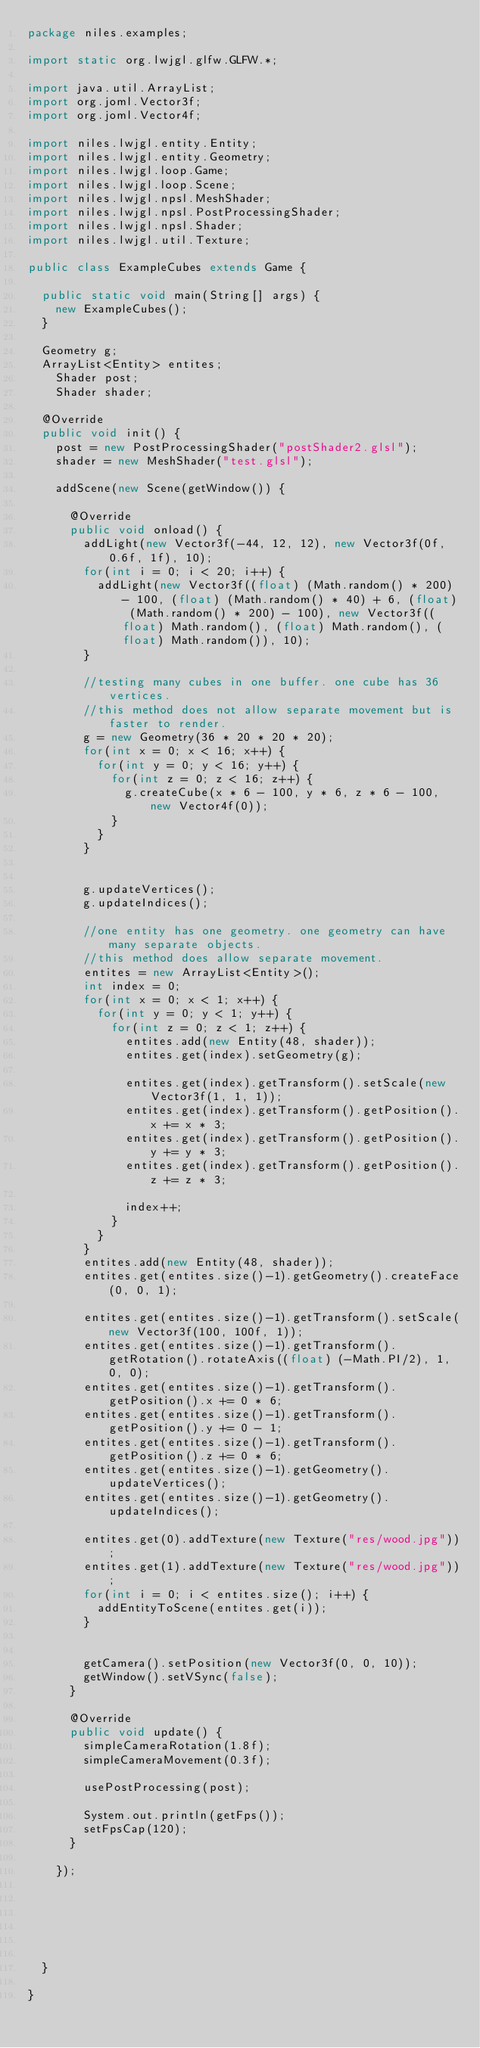<code> <loc_0><loc_0><loc_500><loc_500><_Java_>package niles.examples;

import static org.lwjgl.glfw.GLFW.*;

import java.util.ArrayList;
import org.joml.Vector3f;
import org.joml.Vector4f;

import niles.lwjgl.entity.Entity;
import niles.lwjgl.entity.Geometry;
import niles.lwjgl.loop.Game;
import niles.lwjgl.loop.Scene;
import niles.lwjgl.npsl.MeshShader;
import niles.lwjgl.npsl.PostProcessingShader;
import niles.lwjgl.npsl.Shader;
import niles.lwjgl.util.Texture;

public class ExampleCubes extends Game {

	public static void main(String[] args) {
		new ExampleCubes();
	}
	
	Geometry g;
	ArrayList<Entity> entites;
    Shader post;
    Shader shader;
    
	@Override
	public void init() {
		post = new PostProcessingShader("postShader2.glsl");
		shader = new MeshShader("test.glsl");
		
		addScene(new Scene(getWindow()) {
			
			@Override
			public void onload() {
				addLight(new Vector3f(-44, 12, 12), new Vector3f(0f, 0.6f, 1f), 10);
				for(int i = 0; i < 20; i++) {
					addLight(new Vector3f((float) (Math.random() * 200) - 100, (float) (Math.random() * 40) + 6, (float) (Math.random() * 200) - 100), new Vector3f((float) Math.random(), (float) Math.random(), (float) Math.random()), 10);
				}
				
				//testing many cubes in one buffer. one cube has 36 vertices.
				//this method does not allow separate movement but is faster to render.
				g = new Geometry(36 * 20 * 20 * 20);
				for(int x = 0; x < 16; x++) {
					for(int y = 0; y < 16; y++) {
						for(int z = 0; z < 16; z++) {
							g.createCube(x * 6 - 100, y * 6, z * 6 - 100, new Vector4f(0));
						}
					}
				}
				
				
				g.updateVertices();
				g.updateIndices();
				
				//one entity has one geometry. one geometry can have many separate objects.
				//this method does allow separate movement.
				entites = new ArrayList<Entity>();
				int index = 0;
				for(int x = 0; x < 1; x++) {
					for(int y = 0; y < 1; y++) {
						for(int z = 0; z < 1; z++) {
							entites.add(new Entity(48, shader));
							entites.get(index).setGeometry(g);
							
							entites.get(index).getTransform().setScale(new Vector3f(1, 1, 1));
							entites.get(index).getTransform().getPosition().x += x * 3;
							entites.get(index).getTransform().getPosition().y += y * 3;
							entites.get(index).getTransform().getPosition().z += z * 3;
							
							index++;
						}
					}
				}
				entites.add(new Entity(48, shader));
				entites.get(entites.size()-1).getGeometry().createFace(0, 0, 1);
				
				entites.get(entites.size()-1).getTransform().setScale(new Vector3f(100, 100f, 1));
				entites.get(entites.size()-1).getTransform().getRotation().rotateAxis((float) (-Math.PI/2), 1, 0, 0);
				entites.get(entites.size()-1).getTransform().getPosition().x += 0 * 6;
				entites.get(entites.size()-1).getTransform().getPosition().y += 0 - 1;
				entites.get(entites.size()-1).getTransform().getPosition().z += 0 * 6;
				entites.get(entites.size()-1).getGeometry().updateVertices();
				entites.get(entites.size()-1).getGeometry().updateIndices();
				
				entites.get(0).addTexture(new Texture("res/wood.jpg"));
				entites.get(1).addTexture(new Texture("res/wood.jpg"));
				for(int i = 0; i < entites.size(); i++) {
					addEntityToScene(entites.get(i));
				}
				
				
				getCamera().setPosition(new Vector3f(0, 0, 10));
				getWindow().setVSync(false);
			}
			
			@Override
			public void update() {
				simpleCameraRotation(1.8f);
				simpleCameraMovement(0.3f);
				
				usePostProcessing(post);
				
				System.out.println(getFps());
				setFpsCap(120);
			}
			
		});
		
		
		
		
		
		
	}
	
}
</code> 